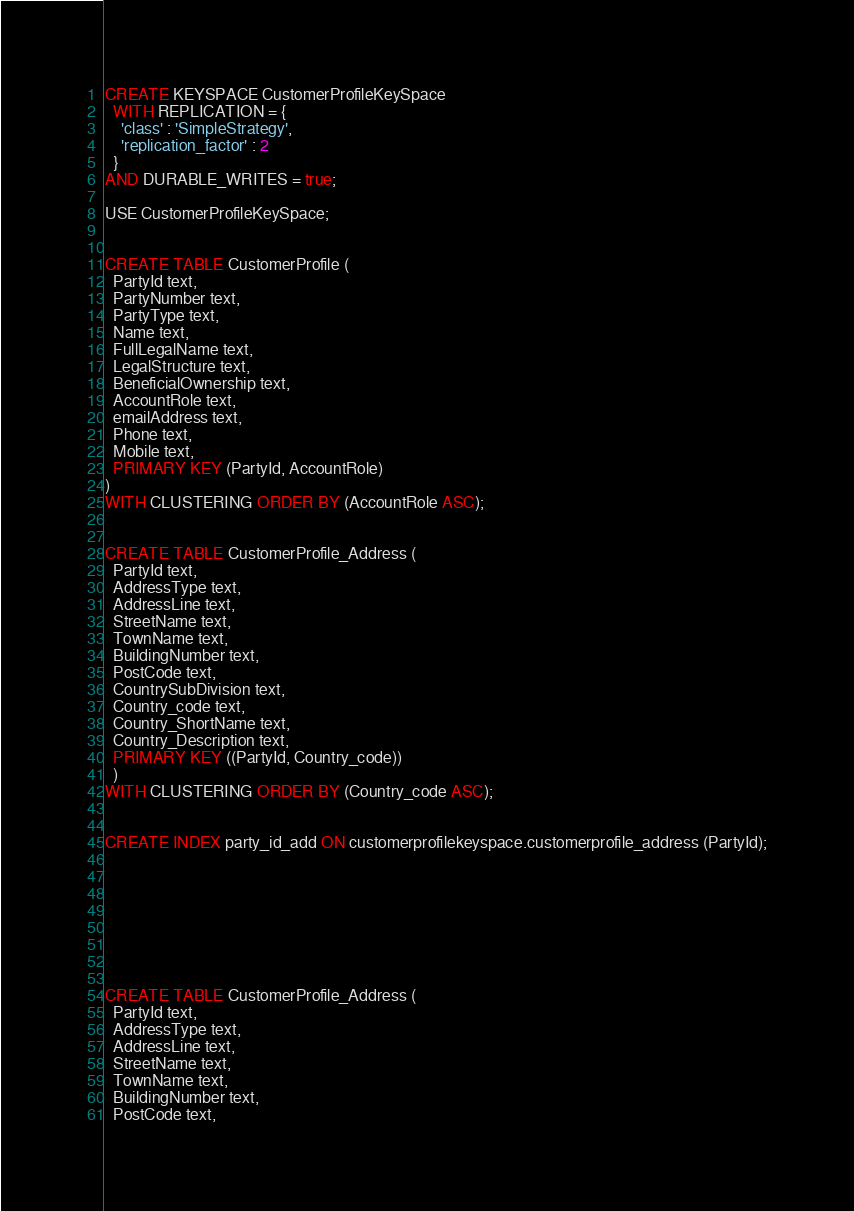Convert code to text. <code><loc_0><loc_0><loc_500><loc_500><_SQL_>CREATE KEYSPACE CustomerProfileKeySpace 
  WITH REPLICATION = {
    'class' : 'SimpleStrategy',
    'replication_factor' : 2
  }
AND DURABLE_WRITES = true; 

USE CustomerProfileKeySpace;


CREATE TABLE CustomerProfile (
  PartyId text,
  PartyNumber text,
  PartyType text,
  Name text,
  FullLegalName text,
  LegalStructure text,
  BeneficialOwnership text,
  AccountRole text,
  emailAddress text,
  Phone text,
  Mobile text,
  PRIMARY KEY (PartyId, AccountRole)
)
WITH CLUSTERING ORDER BY (AccountRole ASC);


CREATE TABLE CustomerProfile_Address (
  PartyId text,
  AddressType text,
  AddressLine text,
  StreetName text,
  TownName text,
  BuildingNumber text,
  PostCode text,
  CountrySubDivision text,
  Country_code text,
  Country_ShortName text,
  Country_Description text,
  PRIMARY KEY ((PartyId, Country_code))
  ) 
WITH CLUSTERING ORDER BY (Country_code ASC);


CREATE INDEX party_id_add ON customerprofilekeyspace.customerprofile_address (PartyId);








CREATE TABLE CustomerProfile_Address (
  PartyId text,
  AddressType text,
  AddressLine text,
  StreetName text,
  TownName text,
  BuildingNumber text,
  PostCode text,</code> 